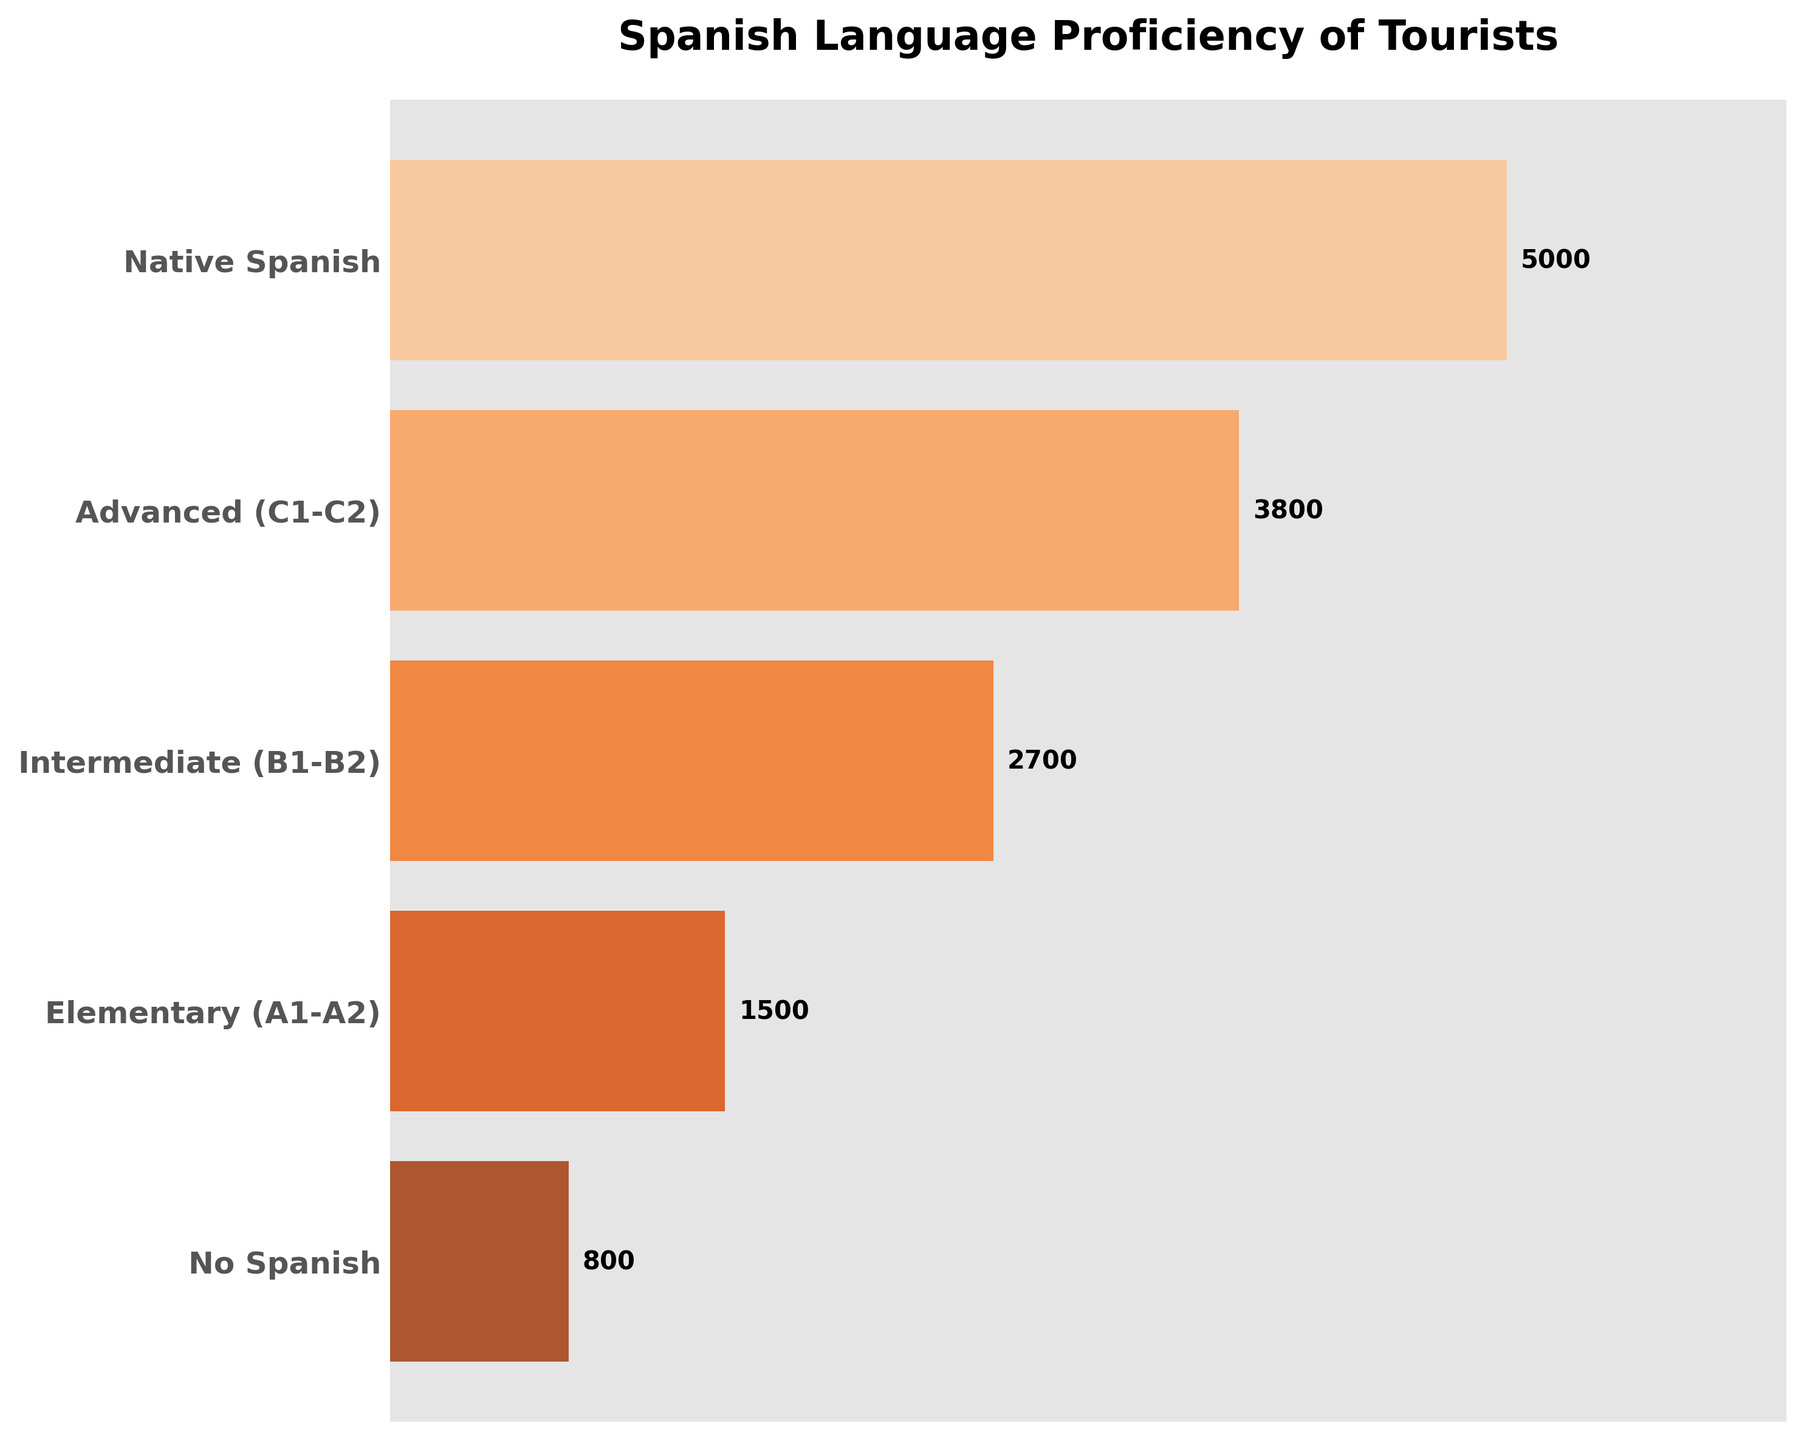How many proficiency levels are indicated in the chart? The chart has different bars for each proficiency level. Counting the bars gives the total number of levels.
Answer: 5 What is the title of the chart? The title can be seen at the top of the chart in bold.
Answer: Spanish Language Proficiency of Tourists Which proficiency level has the fewest tourists? By looking at the shortest bar in the chart, the level with the fewest tourists can be identified.
Answer: No Spanish How many tourists are at the Intermediate (B1-B2) level? The number of tourists corresponding to the Intermediate (B1-B2) level is labeled next to the bar for that level.
Answer: 2700 What is the combined number of tourists at the Elementary (A1-A2) and No Spanish levels? Adding the number of tourists at both the Elementary (A1-A2) level and the No Spanish level gives the combined total.
Answer: 2300 Which level has more tourists: Advanced (C1-C2) or Intermediate (B1-B2)? Comparing the lengths of the bars for Advanced (C1-C2) and Intermediate (B1-B2) levels, the longer bar indicates more tourists.
Answer: Advanced (C1-C2) How many more tourists are Native Spanish speakers compared to those with No Spanish proficiency? Subtract the number of tourists with No Spanish proficiency from the number of Native Spanish speakers.
Answer: 4200 Which proficiency level has the second highest number of tourists? By observing the lengths of the bars, the second longest bar corresponds to the second highest number of tourists.
Answer: Advanced (C1-C2) What percentage of all tourists are Native Spanish speakers? Calculate the total number of tourists first and then divide the number of Native Spanish speakers by this total, multiplying by 100 to get the percentage. The total number of tourists is the sum of all proficiency levels. Total tourists = 5000 + 3800 + 2700 + 1500 + 800 = 13800. Percentage = (5000 / 13800) * 100.
Answer: 36.23% What trend can be observed in the number of tourists as proficiency levels decrease? The trend can be observed by noting how the bar lengths change from the top to the bottom proficiency level.
Answer: Decreasing 